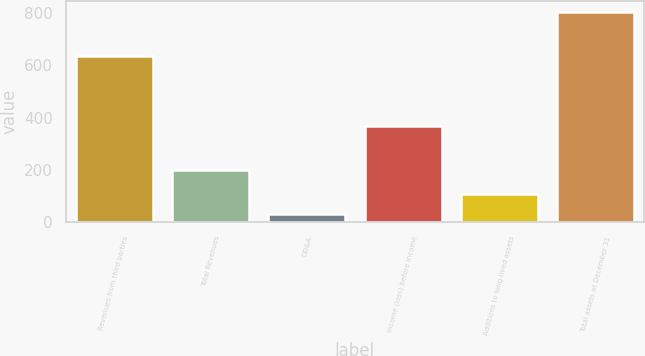Convert chart to OTSL. <chart><loc_0><loc_0><loc_500><loc_500><bar_chart><fcel>Revenues from third parties<fcel>Total Revenues<fcel>DD&A<fcel>Income (loss) before income<fcel>Additions to long-lived assets<fcel>Total assets at December 31<nl><fcel>635<fcel>201<fcel>32<fcel>367<fcel>109.1<fcel>805.1<nl></chart> 